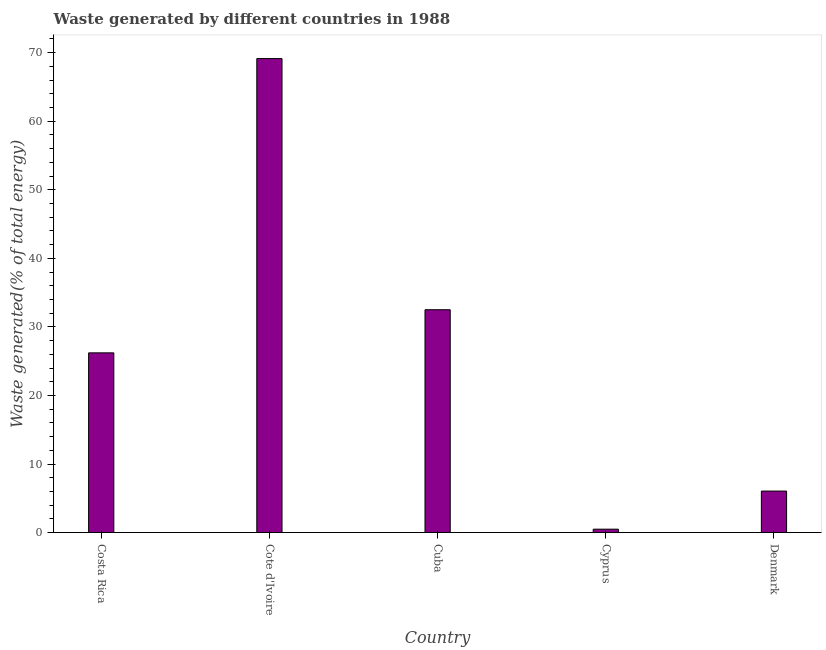Does the graph contain grids?
Keep it short and to the point. No. What is the title of the graph?
Make the answer very short. Waste generated by different countries in 1988. What is the label or title of the X-axis?
Give a very brief answer. Country. What is the label or title of the Y-axis?
Provide a succinct answer. Waste generated(% of total energy). What is the amount of waste generated in Denmark?
Your answer should be compact. 6.06. Across all countries, what is the maximum amount of waste generated?
Your response must be concise. 69.14. Across all countries, what is the minimum amount of waste generated?
Your answer should be compact. 0.5. In which country was the amount of waste generated maximum?
Your response must be concise. Cote d'Ivoire. In which country was the amount of waste generated minimum?
Keep it short and to the point. Cyprus. What is the sum of the amount of waste generated?
Offer a very short reply. 134.41. What is the difference between the amount of waste generated in Cote d'Ivoire and Denmark?
Your answer should be very brief. 63.08. What is the average amount of waste generated per country?
Provide a short and direct response. 26.88. What is the median amount of waste generated?
Make the answer very short. 26.22. What is the ratio of the amount of waste generated in Cote d'Ivoire to that in Denmark?
Your answer should be compact. 11.42. What is the difference between the highest and the second highest amount of waste generated?
Provide a succinct answer. 36.63. What is the difference between the highest and the lowest amount of waste generated?
Your answer should be compact. 68.64. How many bars are there?
Make the answer very short. 5. Are all the bars in the graph horizontal?
Your answer should be very brief. No. How many countries are there in the graph?
Offer a terse response. 5. What is the Waste generated(% of total energy) of Costa Rica?
Provide a succinct answer. 26.22. What is the Waste generated(% of total energy) of Cote d'Ivoire?
Offer a terse response. 69.14. What is the Waste generated(% of total energy) of Cuba?
Offer a terse response. 32.51. What is the Waste generated(% of total energy) of Cyprus?
Offer a terse response. 0.5. What is the Waste generated(% of total energy) of Denmark?
Offer a very short reply. 6.06. What is the difference between the Waste generated(% of total energy) in Costa Rica and Cote d'Ivoire?
Make the answer very short. -42.92. What is the difference between the Waste generated(% of total energy) in Costa Rica and Cuba?
Provide a short and direct response. -6.29. What is the difference between the Waste generated(% of total energy) in Costa Rica and Cyprus?
Provide a succinct answer. 25.72. What is the difference between the Waste generated(% of total energy) in Costa Rica and Denmark?
Give a very brief answer. 20.16. What is the difference between the Waste generated(% of total energy) in Cote d'Ivoire and Cuba?
Your response must be concise. 36.63. What is the difference between the Waste generated(% of total energy) in Cote d'Ivoire and Cyprus?
Your answer should be very brief. 68.64. What is the difference between the Waste generated(% of total energy) in Cote d'Ivoire and Denmark?
Provide a succinct answer. 63.08. What is the difference between the Waste generated(% of total energy) in Cuba and Cyprus?
Your response must be concise. 32.01. What is the difference between the Waste generated(% of total energy) in Cuba and Denmark?
Your answer should be compact. 26.45. What is the difference between the Waste generated(% of total energy) in Cyprus and Denmark?
Offer a very short reply. -5.56. What is the ratio of the Waste generated(% of total energy) in Costa Rica to that in Cote d'Ivoire?
Ensure brevity in your answer.  0.38. What is the ratio of the Waste generated(% of total energy) in Costa Rica to that in Cuba?
Provide a short and direct response. 0.81. What is the ratio of the Waste generated(% of total energy) in Costa Rica to that in Cyprus?
Keep it short and to the point. 52.69. What is the ratio of the Waste generated(% of total energy) in Costa Rica to that in Denmark?
Provide a succinct answer. 4.33. What is the ratio of the Waste generated(% of total energy) in Cote d'Ivoire to that in Cuba?
Your answer should be very brief. 2.13. What is the ratio of the Waste generated(% of total energy) in Cote d'Ivoire to that in Cyprus?
Offer a terse response. 138.94. What is the ratio of the Waste generated(% of total energy) in Cote d'Ivoire to that in Denmark?
Your answer should be compact. 11.42. What is the ratio of the Waste generated(% of total energy) in Cuba to that in Cyprus?
Provide a succinct answer. 65.33. What is the ratio of the Waste generated(% of total energy) in Cuba to that in Denmark?
Ensure brevity in your answer.  5.37. What is the ratio of the Waste generated(% of total energy) in Cyprus to that in Denmark?
Provide a short and direct response. 0.08. 